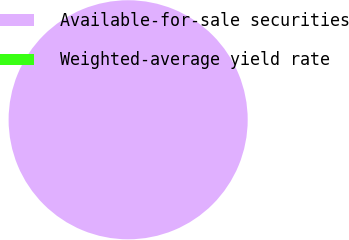Convert chart to OTSL. <chart><loc_0><loc_0><loc_500><loc_500><pie_chart><fcel>Available-for-sale securities<fcel>Weighted-average yield rate<nl><fcel>100.0%<fcel>0.0%<nl></chart> 